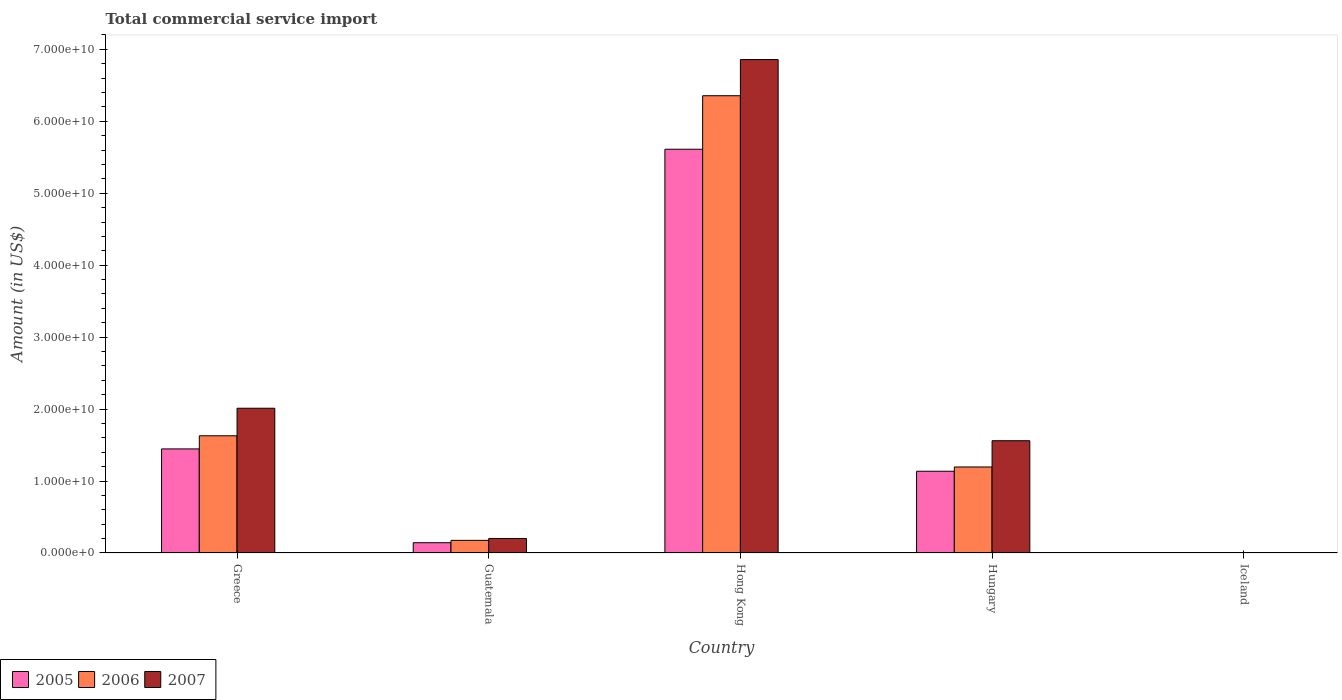How many different coloured bars are there?
Your answer should be very brief. 3. Are the number of bars on each tick of the X-axis equal?
Provide a short and direct response. No. How many bars are there on the 1st tick from the left?
Give a very brief answer. 3. What is the label of the 5th group of bars from the left?
Offer a terse response. Iceland. What is the total commercial service import in 2007 in Guatemala?
Your answer should be compact. 2.02e+09. Across all countries, what is the maximum total commercial service import in 2005?
Your answer should be compact. 5.61e+1. Across all countries, what is the minimum total commercial service import in 2007?
Offer a very short reply. 3.38e+07. In which country was the total commercial service import in 2007 maximum?
Provide a short and direct response. Hong Kong. What is the total total commercial service import in 2006 in the graph?
Ensure brevity in your answer.  9.36e+1. What is the difference between the total commercial service import in 2006 in Hong Kong and that in Iceland?
Your answer should be very brief. 6.35e+1. What is the difference between the total commercial service import in 2006 in Guatemala and the total commercial service import in 2005 in Hong Kong?
Provide a succinct answer. -5.44e+1. What is the average total commercial service import in 2007 per country?
Ensure brevity in your answer.  2.13e+1. What is the difference between the total commercial service import of/in 2006 and total commercial service import of/in 2007 in Guatemala?
Make the answer very short. -2.61e+08. What is the ratio of the total commercial service import in 2005 in Guatemala to that in Hong Kong?
Your answer should be very brief. 0.03. Is the total commercial service import in 2006 in Greece less than that in Iceland?
Your response must be concise. No. Is the difference between the total commercial service import in 2006 in Guatemala and Hong Kong greater than the difference between the total commercial service import in 2007 in Guatemala and Hong Kong?
Your answer should be very brief. Yes. What is the difference between the highest and the second highest total commercial service import in 2005?
Your answer should be compact. -4.16e+1. What is the difference between the highest and the lowest total commercial service import in 2005?
Your answer should be very brief. 5.61e+1. How many bars are there?
Your response must be concise. 14. Are the values on the major ticks of Y-axis written in scientific E-notation?
Your answer should be compact. Yes. Does the graph contain any zero values?
Provide a short and direct response. Yes. How are the legend labels stacked?
Your response must be concise. Horizontal. What is the title of the graph?
Make the answer very short. Total commercial service import. What is the label or title of the X-axis?
Your response must be concise. Country. What is the label or title of the Y-axis?
Offer a terse response. Amount (in US$). What is the Amount (in US$) in 2005 in Greece?
Your response must be concise. 1.45e+1. What is the Amount (in US$) in 2006 in Greece?
Your response must be concise. 1.63e+1. What is the Amount (in US$) in 2007 in Greece?
Offer a terse response. 2.01e+1. What is the Amount (in US$) in 2005 in Guatemala?
Your response must be concise. 1.43e+09. What is the Amount (in US$) in 2006 in Guatemala?
Your response must be concise. 1.76e+09. What is the Amount (in US$) of 2007 in Guatemala?
Offer a terse response. 2.02e+09. What is the Amount (in US$) of 2005 in Hong Kong?
Your answer should be compact. 5.61e+1. What is the Amount (in US$) of 2006 in Hong Kong?
Your response must be concise. 6.35e+1. What is the Amount (in US$) of 2007 in Hong Kong?
Give a very brief answer. 6.86e+1. What is the Amount (in US$) of 2005 in Hungary?
Keep it short and to the point. 1.14e+1. What is the Amount (in US$) of 2006 in Hungary?
Give a very brief answer. 1.20e+1. What is the Amount (in US$) in 2007 in Hungary?
Your answer should be compact. 1.56e+1. What is the Amount (in US$) in 2005 in Iceland?
Ensure brevity in your answer.  0. What is the Amount (in US$) in 2006 in Iceland?
Offer a very short reply. 8.55e+06. What is the Amount (in US$) of 2007 in Iceland?
Offer a very short reply. 3.38e+07. Across all countries, what is the maximum Amount (in US$) in 2005?
Provide a succinct answer. 5.61e+1. Across all countries, what is the maximum Amount (in US$) of 2006?
Give a very brief answer. 6.35e+1. Across all countries, what is the maximum Amount (in US$) in 2007?
Keep it short and to the point. 6.86e+1. Across all countries, what is the minimum Amount (in US$) in 2005?
Make the answer very short. 0. Across all countries, what is the minimum Amount (in US$) in 2006?
Your response must be concise. 8.55e+06. Across all countries, what is the minimum Amount (in US$) of 2007?
Offer a very short reply. 3.38e+07. What is the total Amount (in US$) in 2005 in the graph?
Keep it short and to the point. 8.34e+1. What is the total Amount (in US$) of 2006 in the graph?
Offer a very short reply. 9.36e+1. What is the total Amount (in US$) in 2007 in the graph?
Your response must be concise. 1.06e+11. What is the difference between the Amount (in US$) in 2005 in Greece and that in Guatemala?
Keep it short and to the point. 1.30e+1. What is the difference between the Amount (in US$) in 2006 in Greece and that in Guatemala?
Provide a short and direct response. 1.45e+1. What is the difference between the Amount (in US$) in 2007 in Greece and that in Guatemala?
Provide a succinct answer. 1.81e+1. What is the difference between the Amount (in US$) of 2005 in Greece and that in Hong Kong?
Offer a very short reply. -4.16e+1. What is the difference between the Amount (in US$) of 2006 in Greece and that in Hong Kong?
Make the answer very short. -4.73e+1. What is the difference between the Amount (in US$) in 2007 in Greece and that in Hong Kong?
Your answer should be very brief. -4.85e+1. What is the difference between the Amount (in US$) of 2005 in Greece and that in Hungary?
Your answer should be very brief. 3.10e+09. What is the difference between the Amount (in US$) of 2006 in Greece and that in Hungary?
Provide a short and direct response. 4.34e+09. What is the difference between the Amount (in US$) of 2007 in Greece and that in Hungary?
Keep it short and to the point. 4.51e+09. What is the difference between the Amount (in US$) of 2006 in Greece and that in Iceland?
Give a very brief answer. 1.63e+1. What is the difference between the Amount (in US$) in 2007 in Greece and that in Iceland?
Your answer should be compact. 2.01e+1. What is the difference between the Amount (in US$) in 2005 in Guatemala and that in Hong Kong?
Your answer should be compact. -5.47e+1. What is the difference between the Amount (in US$) in 2006 in Guatemala and that in Hong Kong?
Your answer should be compact. -6.18e+1. What is the difference between the Amount (in US$) in 2007 in Guatemala and that in Hong Kong?
Make the answer very short. -6.66e+1. What is the difference between the Amount (in US$) in 2005 in Guatemala and that in Hungary?
Your answer should be very brief. -9.93e+09. What is the difference between the Amount (in US$) of 2006 in Guatemala and that in Hungary?
Offer a terse response. -1.02e+1. What is the difference between the Amount (in US$) of 2007 in Guatemala and that in Hungary?
Your answer should be compact. -1.36e+1. What is the difference between the Amount (in US$) of 2006 in Guatemala and that in Iceland?
Provide a short and direct response. 1.75e+09. What is the difference between the Amount (in US$) of 2007 in Guatemala and that in Iceland?
Make the answer very short. 1.98e+09. What is the difference between the Amount (in US$) of 2005 in Hong Kong and that in Hungary?
Offer a terse response. 4.48e+1. What is the difference between the Amount (in US$) in 2006 in Hong Kong and that in Hungary?
Your response must be concise. 5.16e+1. What is the difference between the Amount (in US$) of 2007 in Hong Kong and that in Hungary?
Keep it short and to the point. 5.30e+1. What is the difference between the Amount (in US$) of 2006 in Hong Kong and that in Iceland?
Keep it short and to the point. 6.35e+1. What is the difference between the Amount (in US$) of 2007 in Hong Kong and that in Iceland?
Offer a very short reply. 6.85e+1. What is the difference between the Amount (in US$) in 2006 in Hungary and that in Iceland?
Make the answer very short. 1.19e+1. What is the difference between the Amount (in US$) in 2007 in Hungary and that in Iceland?
Ensure brevity in your answer.  1.56e+1. What is the difference between the Amount (in US$) in 2005 in Greece and the Amount (in US$) in 2006 in Guatemala?
Your answer should be very brief. 1.27e+1. What is the difference between the Amount (in US$) of 2005 in Greece and the Amount (in US$) of 2007 in Guatemala?
Offer a terse response. 1.24e+1. What is the difference between the Amount (in US$) in 2006 in Greece and the Amount (in US$) in 2007 in Guatemala?
Your answer should be compact. 1.43e+1. What is the difference between the Amount (in US$) of 2005 in Greece and the Amount (in US$) of 2006 in Hong Kong?
Your answer should be compact. -4.91e+1. What is the difference between the Amount (in US$) in 2005 in Greece and the Amount (in US$) in 2007 in Hong Kong?
Ensure brevity in your answer.  -5.41e+1. What is the difference between the Amount (in US$) of 2006 in Greece and the Amount (in US$) of 2007 in Hong Kong?
Provide a succinct answer. -5.23e+1. What is the difference between the Amount (in US$) in 2005 in Greece and the Amount (in US$) in 2006 in Hungary?
Offer a very short reply. 2.51e+09. What is the difference between the Amount (in US$) in 2005 in Greece and the Amount (in US$) in 2007 in Hungary?
Give a very brief answer. -1.14e+09. What is the difference between the Amount (in US$) of 2006 in Greece and the Amount (in US$) of 2007 in Hungary?
Offer a very short reply. 6.87e+08. What is the difference between the Amount (in US$) in 2005 in Greece and the Amount (in US$) in 2006 in Iceland?
Ensure brevity in your answer.  1.45e+1. What is the difference between the Amount (in US$) in 2005 in Greece and the Amount (in US$) in 2007 in Iceland?
Give a very brief answer. 1.44e+1. What is the difference between the Amount (in US$) in 2006 in Greece and the Amount (in US$) in 2007 in Iceland?
Ensure brevity in your answer.  1.63e+1. What is the difference between the Amount (in US$) of 2005 in Guatemala and the Amount (in US$) of 2006 in Hong Kong?
Your response must be concise. -6.21e+1. What is the difference between the Amount (in US$) in 2005 in Guatemala and the Amount (in US$) in 2007 in Hong Kong?
Ensure brevity in your answer.  -6.71e+1. What is the difference between the Amount (in US$) of 2006 in Guatemala and the Amount (in US$) of 2007 in Hong Kong?
Your answer should be compact. -6.68e+1. What is the difference between the Amount (in US$) of 2005 in Guatemala and the Amount (in US$) of 2006 in Hungary?
Keep it short and to the point. -1.05e+1. What is the difference between the Amount (in US$) in 2005 in Guatemala and the Amount (in US$) in 2007 in Hungary?
Offer a terse response. -1.42e+1. What is the difference between the Amount (in US$) in 2006 in Guatemala and the Amount (in US$) in 2007 in Hungary?
Keep it short and to the point. -1.38e+1. What is the difference between the Amount (in US$) in 2005 in Guatemala and the Amount (in US$) in 2006 in Iceland?
Ensure brevity in your answer.  1.42e+09. What is the difference between the Amount (in US$) of 2005 in Guatemala and the Amount (in US$) of 2007 in Iceland?
Your answer should be compact. 1.40e+09. What is the difference between the Amount (in US$) in 2006 in Guatemala and the Amount (in US$) in 2007 in Iceland?
Make the answer very short. 1.72e+09. What is the difference between the Amount (in US$) of 2005 in Hong Kong and the Amount (in US$) of 2006 in Hungary?
Offer a very short reply. 4.42e+1. What is the difference between the Amount (in US$) in 2005 in Hong Kong and the Amount (in US$) in 2007 in Hungary?
Ensure brevity in your answer.  4.05e+1. What is the difference between the Amount (in US$) of 2006 in Hong Kong and the Amount (in US$) of 2007 in Hungary?
Ensure brevity in your answer.  4.79e+1. What is the difference between the Amount (in US$) of 2005 in Hong Kong and the Amount (in US$) of 2006 in Iceland?
Your answer should be compact. 5.61e+1. What is the difference between the Amount (in US$) in 2005 in Hong Kong and the Amount (in US$) in 2007 in Iceland?
Keep it short and to the point. 5.61e+1. What is the difference between the Amount (in US$) in 2006 in Hong Kong and the Amount (in US$) in 2007 in Iceland?
Give a very brief answer. 6.35e+1. What is the difference between the Amount (in US$) in 2005 in Hungary and the Amount (in US$) in 2006 in Iceland?
Ensure brevity in your answer.  1.14e+1. What is the difference between the Amount (in US$) in 2005 in Hungary and the Amount (in US$) in 2007 in Iceland?
Keep it short and to the point. 1.13e+1. What is the difference between the Amount (in US$) in 2006 in Hungary and the Amount (in US$) in 2007 in Iceland?
Keep it short and to the point. 1.19e+1. What is the average Amount (in US$) in 2005 per country?
Your answer should be compact. 1.67e+1. What is the average Amount (in US$) in 2006 per country?
Provide a short and direct response. 1.87e+1. What is the average Amount (in US$) in 2007 per country?
Offer a terse response. 2.13e+1. What is the difference between the Amount (in US$) of 2005 and Amount (in US$) of 2006 in Greece?
Make the answer very short. -1.83e+09. What is the difference between the Amount (in US$) in 2005 and Amount (in US$) in 2007 in Greece?
Make the answer very short. -5.65e+09. What is the difference between the Amount (in US$) in 2006 and Amount (in US$) in 2007 in Greece?
Your answer should be compact. -3.83e+09. What is the difference between the Amount (in US$) in 2005 and Amount (in US$) in 2006 in Guatemala?
Provide a short and direct response. -3.28e+08. What is the difference between the Amount (in US$) of 2005 and Amount (in US$) of 2007 in Guatemala?
Offer a terse response. -5.88e+08. What is the difference between the Amount (in US$) of 2006 and Amount (in US$) of 2007 in Guatemala?
Your answer should be compact. -2.61e+08. What is the difference between the Amount (in US$) of 2005 and Amount (in US$) of 2006 in Hong Kong?
Make the answer very short. -7.44e+09. What is the difference between the Amount (in US$) in 2005 and Amount (in US$) in 2007 in Hong Kong?
Ensure brevity in your answer.  -1.25e+1. What is the difference between the Amount (in US$) of 2006 and Amount (in US$) of 2007 in Hong Kong?
Your answer should be compact. -5.03e+09. What is the difference between the Amount (in US$) of 2005 and Amount (in US$) of 2006 in Hungary?
Make the answer very short. -5.91e+08. What is the difference between the Amount (in US$) in 2005 and Amount (in US$) in 2007 in Hungary?
Ensure brevity in your answer.  -4.24e+09. What is the difference between the Amount (in US$) of 2006 and Amount (in US$) of 2007 in Hungary?
Offer a terse response. -3.65e+09. What is the difference between the Amount (in US$) of 2006 and Amount (in US$) of 2007 in Iceland?
Your response must be concise. -2.52e+07. What is the ratio of the Amount (in US$) in 2005 in Greece to that in Guatemala?
Your answer should be compact. 10.12. What is the ratio of the Amount (in US$) of 2006 in Greece to that in Guatemala?
Offer a terse response. 9.27. What is the ratio of the Amount (in US$) of 2007 in Greece to that in Guatemala?
Keep it short and to the point. 9.97. What is the ratio of the Amount (in US$) in 2005 in Greece to that in Hong Kong?
Make the answer very short. 0.26. What is the ratio of the Amount (in US$) of 2006 in Greece to that in Hong Kong?
Give a very brief answer. 0.26. What is the ratio of the Amount (in US$) of 2007 in Greece to that in Hong Kong?
Ensure brevity in your answer.  0.29. What is the ratio of the Amount (in US$) of 2005 in Greece to that in Hungary?
Offer a terse response. 1.27. What is the ratio of the Amount (in US$) of 2006 in Greece to that in Hungary?
Keep it short and to the point. 1.36. What is the ratio of the Amount (in US$) of 2007 in Greece to that in Hungary?
Offer a terse response. 1.29. What is the ratio of the Amount (in US$) in 2006 in Greece to that in Iceland?
Provide a short and direct response. 1904.95. What is the ratio of the Amount (in US$) in 2007 in Greece to that in Iceland?
Ensure brevity in your answer.  595.56. What is the ratio of the Amount (in US$) of 2005 in Guatemala to that in Hong Kong?
Keep it short and to the point. 0.03. What is the ratio of the Amount (in US$) of 2006 in Guatemala to that in Hong Kong?
Offer a very short reply. 0.03. What is the ratio of the Amount (in US$) in 2007 in Guatemala to that in Hong Kong?
Your response must be concise. 0.03. What is the ratio of the Amount (in US$) in 2005 in Guatemala to that in Hungary?
Keep it short and to the point. 0.13. What is the ratio of the Amount (in US$) in 2006 in Guatemala to that in Hungary?
Ensure brevity in your answer.  0.15. What is the ratio of the Amount (in US$) of 2007 in Guatemala to that in Hungary?
Your answer should be very brief. 0.13. What is the ratio of the Amount (in US$) in 2006 in Guatemala to that in Iceland?
Make the answer very short. 205.4. What is the ratio of the Amount (in US$) in 2007 in Guatemala to that in Iceland?
Give a very brief answer. 59.72. What is the ratio of the Amount (in US$) of 2005 in Hong Kong to that in Hungary?
Ensure brevity in your answer.  4.94. What is the ratio of the Amount (in US$) in 2006 in Hong Kong to that in Hungary?
Give a very brief answer. 5.32. What is the ratio of the Amount (in US$) of 2007 in Hong Kong to that in Hungary?
Your answer should be compact. 4.4. What is the ratio of the Amount (in US$) of 2006 in Hong Kong to that in Iceland?
Give a very brief answer. 7431.84. What is the ratio of the Amount (in US$) of 2007 in Hong Kong to that in Iceland?
Your answer should be compact. 2030.31. What is the ratio of the Amount (in US$) of 2006 in Hungary to that in Iceland?
Provide a short and direct response. 1397.83. What is the ratio of the Amount (in US$) in 2007 in Hungary to that in Iceland?
Offer a very short reply. 461.9. What is the difference between the highest and the second highest Amount (in US$) of 2005?
Make the answer very short. 4.16e+1. What is the difference between the highest and the second highest Amount (in US$) of 2006?
Give a very brief answer. 4.73e+1. What is the difference between the highest and the second highest Amount (in US$) of 2007?
Ensure brevity in your answer.  4.85e+1. What is the difference between the highest and the lowest Amount (in US$) in 2005?
Your response must be concise. 5.61e+1. What is the difference between the highest and the lowest Amount (in US$) in 2006?
Offer a terse response. 6.35e+1. What is the difference between the highest and the lowest Amount (in US$) of 2007?
Provide a succinct answer. 6.85e+1. 